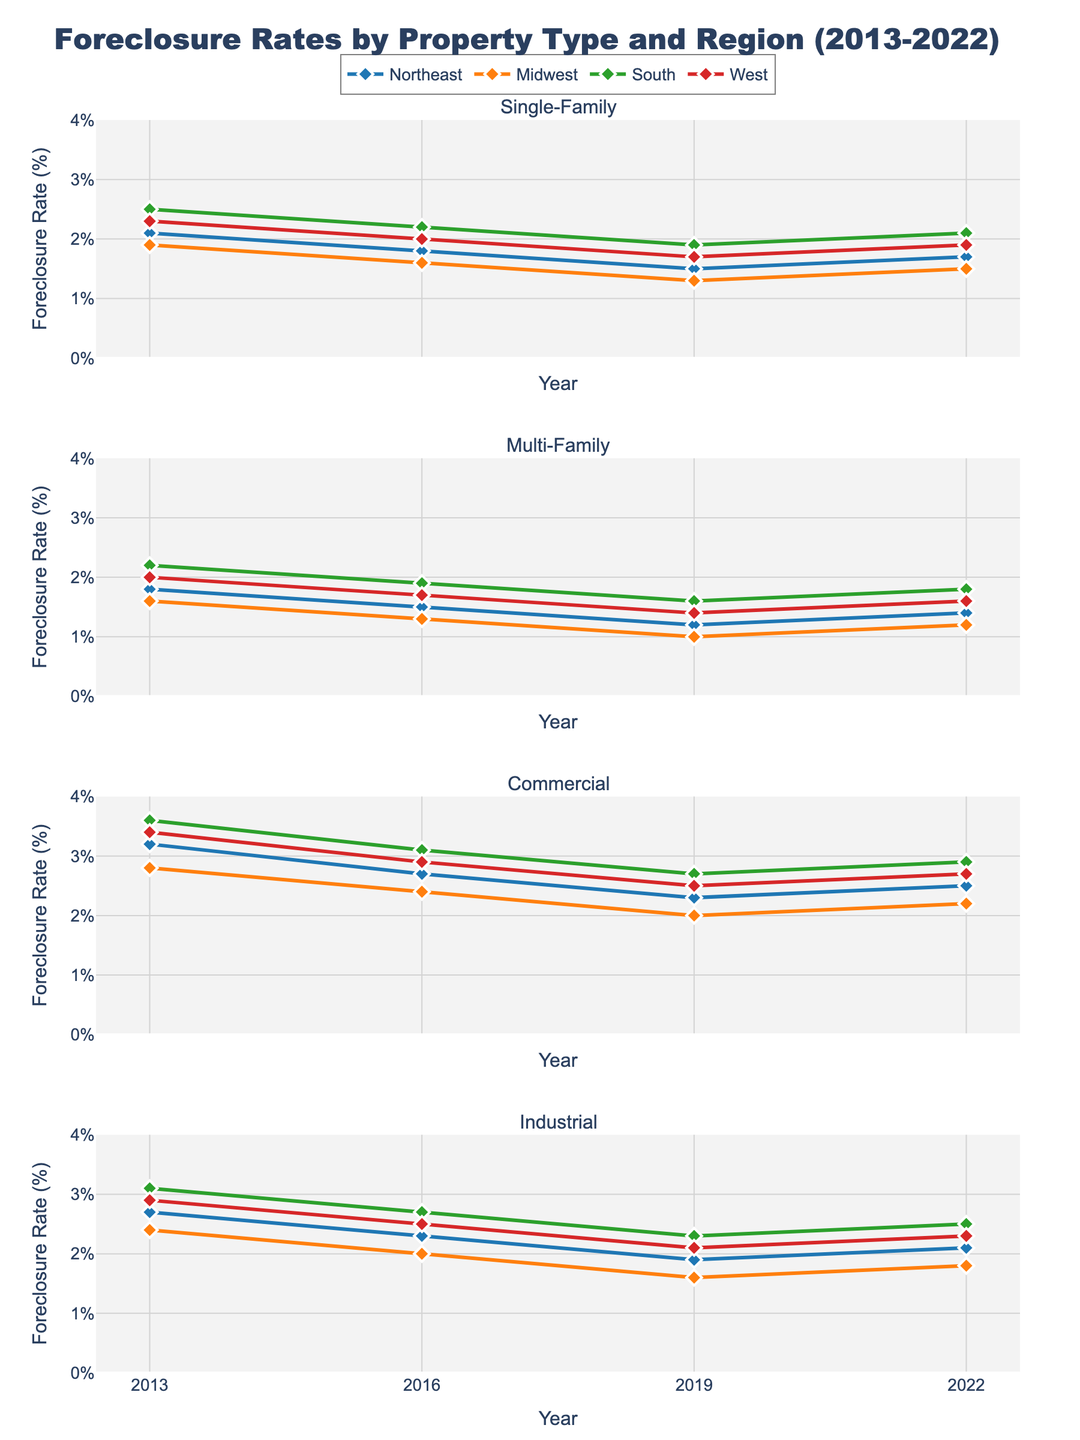What regions are represented in the subplot? The subplot contains traces for four regions, as indicated by the legend: Northeast, Midwest, South, and West.
Answer: Northeast, Midwest, South, and West What is the general trend in foreclosure rates for Single-Family properties from 2013 to 2022? By observing the lines in the Single-Family subplot, we see that foreclosure rates for all regions have generally decreased from 2013 to 2019 and slightly increased or remained stable in 2022.
Answer: Decreased then slightly increased/stable Which property type experienced the highest foreclosure rate in the Northeast in 2013? In the year 2013, looking at the Northeast region across all property type subplots, the highest foreclosure rate of 3.2% is seen in the Commercial property type.
Answer: Commercial Compare the foreclosure rates between Single-Family and Multi-Family properties in the West region for the year 2022. In 2022, the West region's foreclosure rate for Single-Family properties is 1.9%, and for Multi-Family properties, it is 1.6%. The Single-Family rate is 0.3 percentage points higher.
Answer: Single-Family is 0.3% higher What property type in the South region had the highest drop in foreclosure rates from 2013 to 2019? Looking at the data, Commercial properties in the South region had a foreclosure rate of 3.6% in 2013, which dropped to 2.7% in 2019, a decrease of 0.9%.
Answer: Commercial Which region had the lowest foreclosure rate for Industrial properties in 2016? Checking the Industrial property subplot for 2016, the Midwest region had the lowest foreclosure rate of 2.0%.
Answer: Midwest Did the foreclosure rates for Multi-Family properties in the Midwest increase or decrease from 2013 to 2022? By observing the Multi-Family subplot for the Midwest, we see that the rate decreased from 1.6% in 2013 to 1.2% in 2022.
Answer: Decreased For which property type did the South region see the most consistent foreclosure rate trend from 2013 to 2022? In the Industrial property subplot, the South region's foreclosure rates show a consistent trend, varying only slightly between 3.1% and 2.5%.
Answer: Industrial How does the foreclosure rate for Commercial properties in the West in 2019 compare to that in the Northeast in 2022? The foreclosure rate for Commercial properties in the West in 2019 was 2.5%, while for the Northeast in 2022 it was 2.5%. Both rates are the same.
Answer: Same (2.5%) 